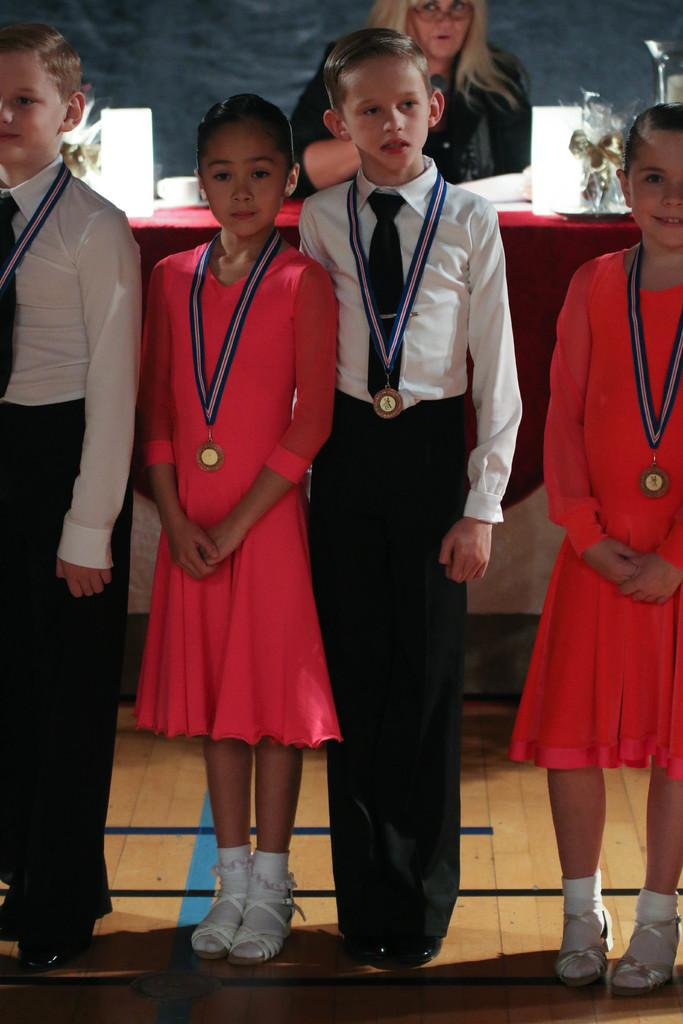How many people with medals are in the image? There are four persons with medals in the image. What are the people with medals doing? The four persons are standing. Can you identify the gender of one of the persons in the image? Yes, there is a woman in the image. What can be seen in the background of the image? In the background, there are items on a table. What type of harbor can be seen in the image? There is no harbor present in the image; it features four persons with medals and a background with items on a table. 